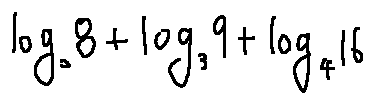Convert formula to latex. <formula><loc_0><loc_0><loc_500><loc_500>\log _ { 2 } 8 + \log _ { 3 } 9 + \log _ { 4 } 1 6</formula> 